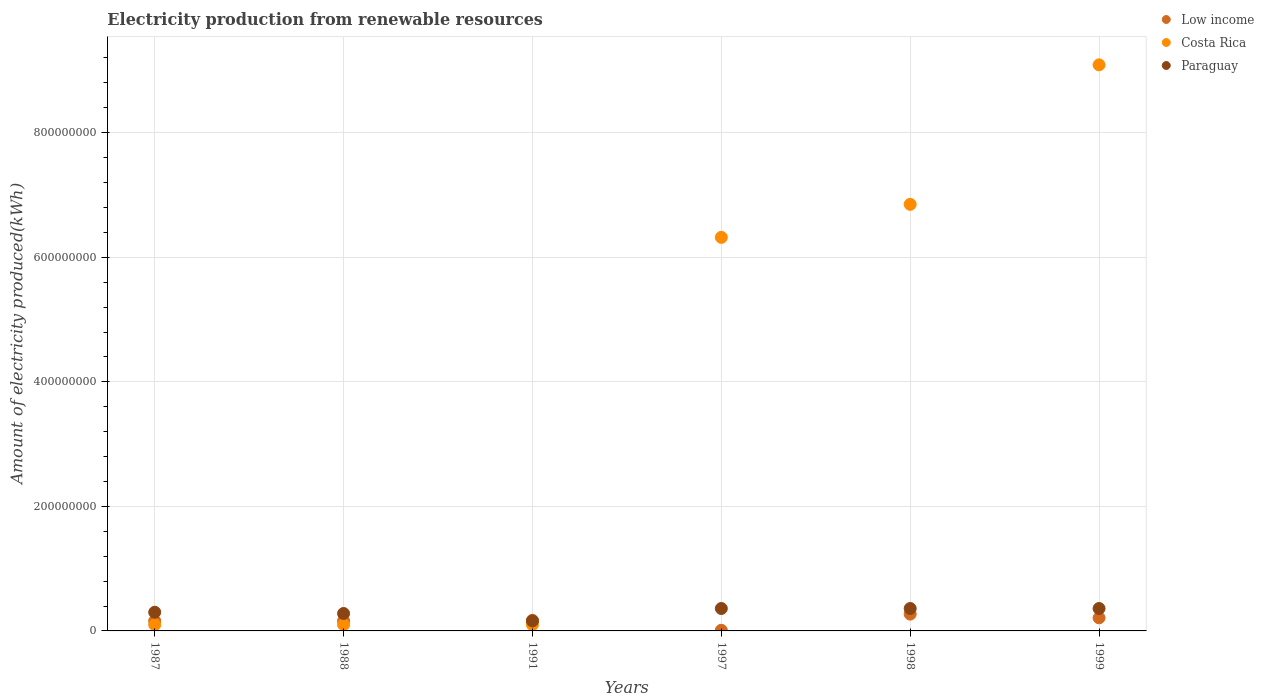What is the amount of electricity produced in Paraguay in 1988?
Give a very brief answer. 2.80e+07. Across all years, what is the maximum amount of electricity produced in Low income?
Offer a very short reply. 2.70e+07. In which year was the amount of electricity produced in Paraguay minimum?
Offer a very short reply. 1991. What is the total amount of electricity produced in Paraguay in the graph?
Your answer should be compact. 1.82e+08. What is the difference between the amount of electricity produced in Paraguay in 1991 and that in 1998?
Provide a short and direct response. -2.00e+07. What is the difference between the amount of electricity produced in Low income in 1998 and the amount of electricity produced in Costa Rica in 1999?
Keep it short and to the point. -8.82e+08. What is the average amount of electricity produced in Paraguay per year?
Offer a terse response. 3.03e+07. In the year 1991, what is the difference between the amount of electricity produced in Paraguay and amount of electricity produced in Costa Rica?
Offer a very short reply. 6.00e+06. Is the amount of electricity produced in Low income in 1987 less than that in 1988?
Your response must be concise. No. What is the difference between the highest and the second highest amount of electricity produced in Costa Rica?
Give a very brief answer. 2.24e+08. What is the difference between the highest and the lowest amount of electricity produced in Costa Rica?
Keep it short and to the point. 8.99e+08. Is it the case that in every year, the sum of the amount of electricity produced in Paraguay and amount of electricity produced in Low income  is greater than the amount of electricity produced in Costa Rica?
Give a very brief answer. No. Does the amount of electricity produced in Paraguay monotonically increase over the years?
Ensure brevity in your answer.  No. Is the amount of electricity produced in Costa Rica strictly greater than the amount of electricity produced in Paraguay over the years?
Give a very brief answer. No. How many years are there in the graph?
Make the answer very short. 6. What is the difference between two consecutive major ticks on the Y-axis?
Give a very brief answer. 2.00e+08. How many legend labels are there?
Your response must be concise. 3. What is the title of the graph?
Your response must be concise. Electricity production from renewable resources. What is the label or title of the X-axis?
Keep it short and to the point. Years. What is the label or title of the Y-axis?
Give a very brief answer. Amount of electricity produced(kWh). What is the Amount of electricity produced(kWh) of Low income in 1987?
Provide a short and direct response. 1.60e+07. What is the Amount of electricity produced(kWh) in Costa Rica in 1987?
Give a very brief answer. 1.00e+07. What is the Amount of electricity produced(kWh) of Paraguay in 1987?
Your answer should be very brief. 3.00e+07. What is the Amount of electricity produced(kWh) of Low income in 1988?
Your answer should be very brief. 1.60e+07. What is the Amount of electricity produced(kWh) in Costa Rica in 1988?
Your answer should be very brief. 1.00e+07. What is the Amount of electricity produced(kWh) of Paraguay in 1988?
Provide a succinct answer. 2.80e+07. What is the Amount of electricity produced(kWh) in Low income in 1991?
Provide a short and direct response. 1.70e+07. What is the Amount of electricity produced(kWh) in Costa Rica in 1991?
Provide a short and direct response. 1.00e+07. What is the Amount of electricity produced(kWh) in Paraguay in 1991?
Offer a very short reply. 1.60e+07. What is the Amount of electricity produced(kWh) of Costa Rica in 1997?
Give a very brief answer. 6.32e+08. What is the Amount of electricity produced(kWh) of Paraguay in 1997?
Your response must be concise. 3.60e+07. What is the Amount of electricity produced(kWh) in Low income in 1998?
Offer a terse response. 2.70e+07. What is the Amount of electricity produced(kWh) in Costa Rica in 1998?
Keep it short and to the point. 6.85e+08. What is the Amount of electricity produced(kWh) in Paraguay in 1998?
Ensure brevity in your answer.  3.60e+07. What is the Amount of electricity produced(kWh) in Low income in 1999?
Your answer should be very brief. 2.10e+07. What is the Amount of electricity produced(kWh) in Costa Rica in 1999?
Ensure brevity in your answer.  9.09e+08. What is the Amount of electricity produced(kWh) in Paraguay in 1999?
Offer a very short reply. 3.60e+07. Across all years, what is the maximum Amount of electricity produced(kWh) of Low income?
Keep it short and to the point. 2.70e+07. Across all years, what is the maximum Amount of electricity produced(kWh) of Costa Rica?
Your answer should be compact. 9.09e+08. Across all years, what is the maximum Amount of electricity produced(kWh) of Paraguay?
Ensure brevity in your answer.  3.60e+07. Across all years, what is the minimum Amount of electricity produced(kWh) in Low income?
Ensure brevity in your answer.  1.00e+06. Across all years, what is the minimum Amount of electricity produced(kWh) in Paraguay?
Offer a very short reply. 1.60e+07. What is the total Amount of electricity produced(kWh) in Low income in the graph?
Give a very brief answer. 9.80e+07. What is the total Amount of electricity produced(kWh) of Costa Rica in the graph?
Make the answer very short. 2.26e+09. What is the total Amount of electricity produced(kWh) of Paraguay in the graph?
Provide a short and direct response. 1.82e+08. What is the difference between the Amount of electricity produced(kWh) in Paraguay in 1987 and that in 1988?
Your response must be concise. 2.00e+06. What is the difference between the Amount of electricity produced(kWh) in Paraguay in 1987 and that in 1991?
Ensure brevity in your answer.  1.40e+07. What is the difference between the Amount of electricity produced(kWh) in Low income in 1987 and that in 1997?
Your answer should be very brief. 1.50e+07. What is the difference between the Amount of electricity produced(kWh) of Costa Rica in 1987 and that in 1997?
Provide a succinct answer. -6.22e+08. What is the difference between the Amount of electricity produced(kWh) in Paraguay in 1987 and that in 1997?
Ensure brevity in your answer.  -6.00e+06. What is the difference between the Amount of electricity produced(kWh) in Low income in 1987 and that in 1998?
Offer a terse response. -1.10e+07. What is the difference between the Amount of electricity produced(kWh) of Costa Rica in 1987 and that in 1998?
Provide a short and direct response. -6.75e+08. What is the difference between the Amount of electricity produced(kWh) in Paraguay in 1987 and that in 1998?
Your response must be concise. -6.00e+06. What is the difference between the Amount of electricity produced(kWh) in Low income in 1987 and that in 1999?
Your answer should be compact. -5.00e+06. What is the difference between the Amount of electricity produced(kWh) of Costa Rica in 1987 and that in 1999?
Provide a succinct answer. -8.99e+08. What is the difference between the Amount of electricity produced(kWh) in Paraguay in 1987 and that in 1999?
Give a very brief answer. -6.00e+06. What is the difference between the Amount of electricity produced(kWh) in Paraguay in 1988 and that in 1991?
Ensure brevity in your answer.  1.20e+07. What is the difference between the Amount of electricity produced(kWh) of Low income in 1988 and that in 1997?
Offer a terse response. 1.50e+07. What is the difference between the Amount of electricity produced(kWh) in Costa Rica in 1988 and that in 1997?
Your answer should be compact. -6.22e+08. What is the difference between the Amount of electricity produced(kWh) of Paraguay in 1988 and that in 1997?
Give a very brief answer. -8.00e+06. What is the difference between the Amount of electricity produced(kWh) of Low income in 1988 and that in 1998?
Offer a terse response. -1.10e+07. What is the difference between the Amount of electricity produced(kWh) in Costa Rica in 1988 and that in 1998?
Give a very brief answer. -6.75e+08. What is the difference between the Amount of electricity produced(kWh) of Paraguay in 1988 and that in 1998?
Offer a terse response. -8.00e+06. What is the difference between the Amount of electricity produced(kWh) of Low income in 1988 and that in 1999?
Keep it short and to the point. -5.00e+06. What is the difference between the Amount of electricity produced(kWh) of Costa Rica in 1988 and that in 1999?
Offer a very short reply. -8.99e+08. What is the difference between the Amount of electricity produced(kWh) of Paraguay in 1988 and that in 1999?
Offer a very short reply. -8.00e+06. What is the difference between the Amount of electricity produced(kWh) in Low income in 1991 and that in 1997?
Provide a short and direct response. 1.60e+07. What is the difference between the Amount of electricity produced(kWh) in Costa Rica in 1991 and that in 1997?
Offer a terse response. -6.22e+08. What is the difference between the Amount of electricity produced(kWh) of Paraguay in 1991 and that in 1997?
Your answer should be very brief. -2.00e+07. What is the difference between the Amount of electricity produced(kWh) in Low income in 1991 and that in 1998?
Give a very brief answer. -1.00e+07. What is the difference between the Amount of electricity produced(kWh) of Costa Rica in 1991 and that in 1998?
Ensure brevity in your answer.  -6.75e+08. What is the difference between the Amount of electricity produced(kWh) in Paraguay in 1991 and that in 1998?
Your response must be concise. -2.00e+07. What is the difference between the Amount of electricity produced(kWh) in Costa Rica in 1991 and that in 1999?
Offer a terse response. -8.99e+08. What is the difference between the Amount of electricity produced(kWh) of Paraguay in 1991 and that in 1999?
Offer a terse response. -2.00e+07. What is the difference between the Amount of electricity produced(kWh) in Low income in 1997 and that in 1998?
Make the answer very short. -2.60e+07. What is the difference between the Amount of electricity produced(kWh) in Costa Rica in 1997 and that in 1998?
Provide a succinct answer. -5.30e+07. What is the difference between the Amount of electricity produced(kWh) in Low income in 1997 and that in 1999?
Offer a terse response. -2.00e+07. What is the difference between the Amount of electricity produced(kWh) in Costa Rica in 1997 and that in 1999?
Make the answer very short. -2.77e+08. What is the difference between the Amount of electricity produced(kWh) in Costa Rica in 1998 and that in 1999?
Keep it short and to the point. -2.24e+08. What is the difference between the Amount of electricity produced(kWh) in Low income in 1987 and the Amount of electricity produced(kWh) in Costa Rica in 1988?
Offer a very short reply. 6.00e+06. What is the difference between the Amount of electricity produced(kWh) of Low income in 1987 and the Amount of electricity produced(kWh) of Paraguay in 1988?
Offer a very short reply. -1.20e+07. What is the difference between the Amount of electricity produced(kWh) of Costa Rica in 1987 and the Amount of electricity produced(kWh) of Paraguay in 1988?
Your answer should be very brief. -1.80e+07. What is the difference between the Amount of electricity produced(kWh) in Low income in 1987 and the Amount of electricity produced(kWh) in Costa Rica in 1991?
Ensure brevity in your answer.  6.00e+06. What is the difference between the Amount of electricity produced(kWh) in Low income in 1987 and the Amount of electricity produced(kWh) in Paraguay in 1991?
Ensure brevity in your answer.  0. What is the difference between the Amount of electricity produced(kWh) of Costa Rica in 1987 and the Amount of electricity produced(kWh) of Paraguay in 1991?
Provide a succinct answer. -6.00e+06. What is the difference between the Amount of electricity produced(kWh) in Low income in 1987 and the Amount of electricity produced(kWh) in Costa Rica in 1997?
Provide a short and direct response. -6.16e+08. What is the difference between the Amount of electricity produced(kWh) in Low income in 1987 and the Amount of electricity produced(kWh) in Paraguay in 1997?
Your answer should be very brief. -2.00e+07. What is the difference between the Amount of electricity produced(kWh) of Costa Rica in 1987 and the Amount of electricity produced(kWh) of Paraguay in 1997?
Provide a short and direct response. -2.60e+07. What is the difference between the Amount of electricity produced(kWh) of Low income in 1987 and the Amount of electricity produced(kWh) of Costa Rica in 1998?
Provide a succinct answer. -6.69e+08. What is the difference between the Amount of electricity produced(kWh) of Low income in 1987 and the Amount of electricity produced(kWh) of Paraguay in 1998?
Keep it short and to the point. -2.00e+07. What is the difference between the Amount of electricity produced(kWh) in Costa Rica in 1987 and the Amount of electricity produced(kWh) in Paraguay in 1998?
Ensure brevity in your answer.  -2.60e+07. What is the difference between the Amount of electricity produced(kWh) of Low income in 1987 and the Amount of electricity produced(kWh) of Costa Rica in 1999?
Give a very brief answer. -8.93e+08. What is the difference between the Amount of electricity produced(kWh) of Low income in 1987 and the Amount of electricity produced(kWh) of Paraguay in 1999?
Ensure brevity in your answer.  -2.00e+07. What is the difference between the Amount of electricity produced(kWh) in Costa Rica in 1987 and the Amount of electricity produced(kWh) in Paraguay in 1999?
Make the answer very short. -2.60e+07. What is the difference between the Amount of electricity produced(kWh) in Low income in 1988 and the Amount of electricity produced(kWh) in Costa Rica in 1991?
Ensure brevity in your answer.  6.00e+06. What is the difference between the Amount of electricity produced(kWh) in Low income in 1988 and the Amount of electricity produced(kWh) in Paraguay in 1991?
Provide a short and direct response. 0. What is the difference between the Amount of electricity produced(kWh) of Costa Rica in 1988 and the Amount of electricity produced(kWh) of Paraguay in 1991?
Offer a very short reply. -6.00e+06. What is the difference between the Amount of electricity produced(kWh) of Low income in 1988 and the Amount of electricity produced(kWh) of Costa Rica in 1997?
Make the answer very short. -6.16e+08. What is the difference between the Amount of electricity produced(kWh) in Low income in 1988 and the Amount of electricity produced(kWh) in Paraguay in 1997?
Your answer should be compact. -2.00e+07. What is the difference between the Amount of electricity produced(kWh) of Costa Rica in 1988 and the Amount of electricity produced(kWh) of Paraguay in 1997?
Provide a short and direct response. -2.60e+07. What is the difference between the Amount of electricity produced(kWh) of Low income in 1988 and the Amount of electricity produced(kWh) of Costa Rica in 1998?
Your answer should be compact. -6.69e+08. What is the difference between the Amount of electricity produced(kWh) of Low income in 1988 and the Amount of electricity produced(kWh) of Paraguay in 1998?
Provide a succinct answer. -2.00e+07. What is the difference between the Amount of electricity produced(kWh) of Costa Rica in 1988 and the Amount of electricity produced(kWh) of Paraguay in 1998?
Your answer should be compact. -2.60e+07. What is the difference between the Amount of electricity produced(kWh) of Low income in 1988 and the Amount of electricity produced(kWh) of Costa Rica in 1999?
Provide a short and direct response. -8.93e+08. What is the difference between the Amount of electricity produced(kWh) in Low income in 1988 and the Amount of electricity produced(kWh) in Paraguay in 1999?
Your answer should be very brief. -2.00e+07. What is the difference between the Amount of electricity produced(kWh) in Costa Rica in 1988 and the Amount of electricity produced(kWh) in Paraguay in 1999?
Provide a short and direct response. -2.60e+07. What is the difference between the Amount of electricity produced(kWh) in Low income in 1991 and the Amount of electricity produced(kWh) in Costa Rica in 1997?
Your answer should be very brief. -6.15e+08. What is the difference between the Amount of electricity produced(kWh) in Low income in 1991 and the Amount of electricity produced(kWh) in Paraguay in 1997?
Keep it short and to the point. -1.90e+07. What is the difference between the Amount of electricity produced(kWh) of Costa Rica in 1991 and the Amount of electricity produced(kWh) of Paraguay in 1997?
Give a very brief answer. -2.60e+07. What is the difference between the Amount of electricity produced(kWh) of Low income in 1991 and the Amount of electricity produced(kWh) of Costa Rica in 1998?
Give a very brief answer. -6.68e+08. What is the difference between the Amount of electricity produced(kWh) of Low income in 1991 and the Amount of electricity produced(kWh) of Paraguay in 1998?
Make the answer very short. -1.90e+07. What is the difference between the Amount of electricity produced(kWh) of Costa Rica in 1991 and the Amount of electricity produced(kWh) of Paraguay in 1998?
Your answer should be very brief. -2.60e+07. What is the difference between the Amount of electricity produced(kWh) of Low income in 1991 and the Amount of electricity produced(kWh) of Costa Rica in 1999?
Offer a very short reply. -8.92e+08. What is the difference between the Amount of electricity produced(kWh) in Low income in 1991 and the Amount of electricity produced(kWh) in Paraguay in 1999?
Your answer should be very brief. -1.90e+07. What is the difference between the Amount of electricity produced(kWh) in Costa Rica in 1991 and the Amount of electricity produced(kWh) in Paraguay in 1999?
Provide a succinct answer. -2.60e+07. What is the difference between the Amount of electricity produced(kWh) in Low income in 1997 and the Amount of electricity produced(kWh) in Costa Rica in 1998?
Keep it short and to the point. -6.84e+08. What is the difference between the Amount of electricity produced(kWh) of Low income in 1997 and the Amount of electricity produced(kWh) of Paraguay in 1998?
Your answer should be very brief. -3.50e+07. What is the difference between the Amount of electricity produced(kWh) in Costa Rica in 1997 and the Amount of electricity produced(kWh) in Paraguay in 1998?
Make the answer very short. 5.96e+08. What is the difference between the Amount of electricity produced(kWh) of Low income in 1997 and the Amount of electricity produced(kWh) of Costa Rica in 1999?
Offer a very short reply. -9.08e+08. What is the difference between the Amount of electricity produced(kWh) of Low income in 1997 and the Amount of electricity produced(kWh) of Paraguay in 1999?
Your answer should be very brief. -3.50e+07. What is the difference between the Amount of electricity produced(kWh) of Costa Rica in 1997 and the Amount of electricity produced(kWh) of Paraguay in 1999?
Make the answer very short. 5.96e+08. What is the difference between the Amount of electricity produced(kWh) of Low income in 1998 and the Amount of electricity produced(kWh) of Costa Rica in 1999?
Keep it short and to the point. -8.82e+08. What is the difference between the Amount of electricity produced(kWh) of Low income in 1998 and the Amount of electricity produced(kWh) of Paraguay in 1999?
Provide a short and direct response. -9.00e+06. What is the difference between the Amount of electricity produced(kWh) in Costa Rica in 1998 and the Amount of electricity produced(kWh) in Paraguay in 1999?
Provide a short and direct response. 6.49e+08. What is the average Amount of electricity produced(kWh) of Low income per year?
Offer a very short reply. 1.63e+07. What is the average Amount of electricity produced(kWh) of Costa Rica per year?
Keep it short and to the point. 3.76e+08. What is the average Amount of electricity produced(kWh) in Paraguay per year?
Keep it short and to the point. 3.03e+07. In the year 1987, what is the difference between the Amount of electricity produced(kWh) of Low income and Amount of electricity produced(kWh) of Paraguay?
Provide a succinct answer. -1.40e+07. In the year 1987, what is the difference between the Amount of electricity produced(kWh) of Costa Rica and Amount of electricity produced(kWh) of Paraguay?
Offer a terse response. -2.00e+07. In the year 1988, what is the difference between the Amount of electricity produced(kWh) in Low income and Amount of electricity produced(kWh) in Paraguay?
Provide a short and direct response. -1.20e+07. In the year 1988, what is the difference between the Amount of electricity produced(kWh) of Costa Rica and Amount of electricity produced(kWh) of Paraguay?
Your answer should be compact. -1.80e+07. In the year 1991, what is the difference between the Amount of electricity produced(kWh) in Costa Rica and Amount of electricity produced(kWh) in Paraguay?
Your response must be concise. -6.00e+06. In the year 1997, what is the difference between the Amount of electricity produced(kWh) in Low income and Amount of electricity produced(kWh) in Costa Rica?
Give a very brief answer. -6.31e+08. In the year 1997, what is the difference between the Amount of electricity produced(kWh) of Low income and Amount of electricity produced(kWh) of Paraguay?
Offer a very short reply. -3.50e+07. In the year 1997, what is the difference between the Amount of electricity produced(kWh) of Costa Rica and Amount of electricity produced(kWh) of Paraguay?
Your answer should be compact. 5.96e+08. In the year 1998, what is the difference between the Amount of electricity produced(kWh) of Low income and Amount of electricity produced(kWh) of Costa Rica?
Ensure brevity in your answer.  -6.58e+08. In the year 1998, what is the difference between the Amount of electricity produced(kWh) in Low income and Amount of electricity produced(kWh) in Paraguay?
Give a very brief answer. -9.00e+06. In the year 1998, what is the difference between the Amount of electricity produced(kWh) in Costa Rica and Amount of electricity produced(kWh) in Paraguay?
Provide a succinct answer. 6.49e+08. In the year 1999, what is the difference between the Amount of electricity produced(kWh) of Low income and Amount of electricity produced(kWh) of Costa Rica?
Provide a short and direct response. -8.88e+08. In the year 1999, what is the difference between the Amount of electricity produced(kWh) in Low income and Amount of electricity produced(kWh) in Paraguay?
Keep it short and to the point. -1.50e+07. In the year 1999, what is the difference between the Amount of electricity produced(kWh) of Costa Rica and Amount of electricity produced(kWh) of Paraguay?
Keep it short and to the point. 8.73e+08. What is the ratio of the Amount of electricity produced(kWh) of Low income in 1987 to that in 1988?
Make the answer very short. 1. What is the ratio of the Amount of electricity produced(kWh) of Costa Rica in 1987 to that in 1988?
Keep it short and to the point. 1. What is the ratio of the Amount of electricity produced(kWh) of Paraguay in 1987 to that in 1988?
Provide a short and direct response. 1.07. What is the ratio of the Amount of electricity produced(kWh) in Low income in 1987 to that in 1991?
Make the answer very short. 0.94. What is the ratio of the Amount of electricity produced(kWh) of Costa Rica in 1987 to that in 1991?
Offer a very short reply. 1. What is the ratio of the Amount of electricity produced(kWh) in Paraguay in 1987 to that in 1991?
Offer a very short reply. 1.88. What is the ratio of the Amount of electricity produced(kWh) in Low income in 1987 to that in 1997?
Offer a terse response. 16. What is the ratio of the Amount of electricity produced(kWh) in Costa Rica in 1987 to that in 1997?
Offer a very short reply. 0.02. What is the ratio of the Amount of electricity produced(kWh) of Low income in 1987 to that in 1998?
Provide a short and direct response. 0.59. What is the ratio of the Amount of electricity produced(kWh) in Costa Rica in 1987 to that in 1998?
Keep it short and to the point. 0.01. What is the ratio of the Amount of electricity produced(kWh) in Paraguay in 1987 to that in 1998?
Offer a very short reply. 0.83. What is the ratio of the Amount of electricity produced(kWh) of Low income in 1987 to that in 1999?
Make the answer very short. 0.76. What is the ratio of the Amount of electricity produced(kWh) in Costa Rica in 1987 to that in 1999?
Make the answer very short. 0.01. What is the ratio of the Amount of electricity produced(kWh) of Paraguay in 1987 to that in 1999?
Provide a short and direct response. 0.83. What is the ratio of the Amount of electricity produced(kWh) of Costa Rica in 1988 to that in 1991?
Offer a terse response. 1. What is the ratio of the Amount of electricity produced(kWh) of Paraguay in 1988 to that in 1991?
Give a very brief answer. 1.75. What is the ratio of the Amount of electricity produced(kWh) of Low income in 1988 to that in 1997?
Keep it short and to the point. 16. What is the ratio of the Amount of electricity produced(kWh) in Costa Rica in 1988 to that in 1997?
Provide a succinct answer. 0.02. What is the ratio of the Amount of electricity produced(kWh) in Paraguay in 1988 to that in 1997?
Provide a succinct answer. 0.78. What is the ratio of the Amount of electricity produced(kWh) in Low income in 1988 to that in 1998?
Make the answer very short. 0.59. What is the ratio of the Amount of electricity produced(kWh) in Costa Rica in 1988 to that in 1998?
Your answer should be very brief. 0.01. What is the ratio of the Amount of electricity produced(kWh) of Low income in 1988 to that in 1999?
Offer a very short reply. 0.76. What is the ratio of the Amount of electricity produced(kWh) of Costa Rica in 1988 to that in 1999?
Ensure brevity in your answer.  0.01. What is the ratio of the Amount of electricity produced(kWh) in Costa Rica in 1991 to that in 1997?
Give a very brief answer. 0.02. What is the ratio of the Amount of electricity produced(kWh) in Paraguay in 1991 to that in 1997?
Ensure brevity in your answer.  0.44. What is the ratio of the Amount of electricity produced(kWh) of Low income in 1991 to that in 1998?
Provide a succinct answer. 0.63. What is the ratio of the Amount of electricity produced(kWh) in Costa Rica in 1991 to that in 1998?
Ensure brevity in your answer.  0.01. What is the ratio of the Amount of electricity produced(kWh) of Paraguay in 1991 to that in 1998?
Provide a short and direct response. 0.44. What is the ratio of the Amount of electricity produced(kWh) of Low income in 1991 to that in 1999?
Your answer should be very brief. 0.81. What is the ratio of the Amount of electricity produced(kWh) of Costa Rica in 1991 to that in 1999?
Keep it short and to the point. 0.01. What is the ratio of the Amount of electricity produced(kWh) in Paraguay in 1991 to that in 1999?
Your answer should be compact. 0.44. What is the ratio of the Amount of electricity produced(kWh) in Low income in 1997 to that in 1998?
Provide a succinct answer. 0.04. What is the ratio of the Amount of electricity produced(kWh) in Costa Rica in 1997 to that in 1998?
Provide a short and direct response. 0.92. What is the ratio of the Amount of electricity produced(kWh) in Paraguay in 1997 to that in 1998?
Your answer should be very brief. 1. What is the ratio of the Amount of electricity produced(kWh) of Low income in 1997 to that in 1999?
Ensure brevity in your answer.  0.05. What is the ratio of the Amount of electricity produced(kWh) of Costa Rica in 1997 to that in 1999?
Keep it short and to the point. 0.7. What is the ratio of the Amount of electricity produced(kWh) in Paraguay in 1997 to that in 1999?
Your answer should be compact. 1. What is the ratio of the Amount of electricity produced(kWh) of Low income in 1998 to that in 1999?
Provide a succinct answer. 1.29. What is the ratio of the Amount of electricity produced(kWh) in Costa Rica in 1998 to that in 1999?
Offer a terse response. 0.75. What is the difference between the highest and the second highest Amount of electricity produced(kWh) in Low income?
Provide a short and direct response. 6.00e+06. What is the difference between the highest and the second highest Amount of electricity produced(kWh) of Costa Rica?
Provide a succinct answer. 2.24e+08. What is the difference between the highest and the second highest Amount of electricity produced(kWh) of Paraguay?
Your answer should be compact. 0. What is the difference between the highest and the lowest Amount of electricity produced(kWh) in Low income?
Your answer should be very brief. 2.60e+07. What is the difference between the highest and the lowest Amount of electricity produced(kWh) of Costa Rica?
Give a very brief answer. 8.99e+08. What is the difference between the highest and the lowest Amount of electricity produced(kWh) in Paraguay?
Offer a very short reply. 2.00e+07. 